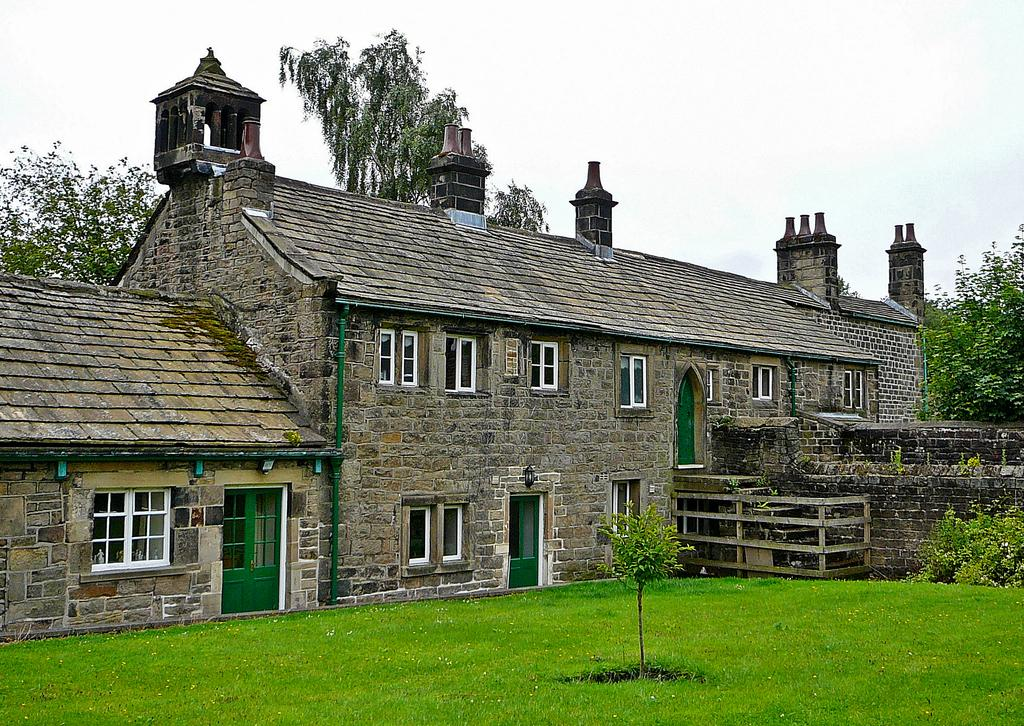What type of structures can be seen in the image? There are buildings in the image. What type of vegetation is present in the image? There are trees and grass in the image. What type of illumination is visible in the image? There are lights in the image. What type of object can be seen on a wall in the image? There is a pipe on a wall in the image. What type of songs can be heard playing in the image? There is no indication of any songs playing in the image, as it only contains visual information. 